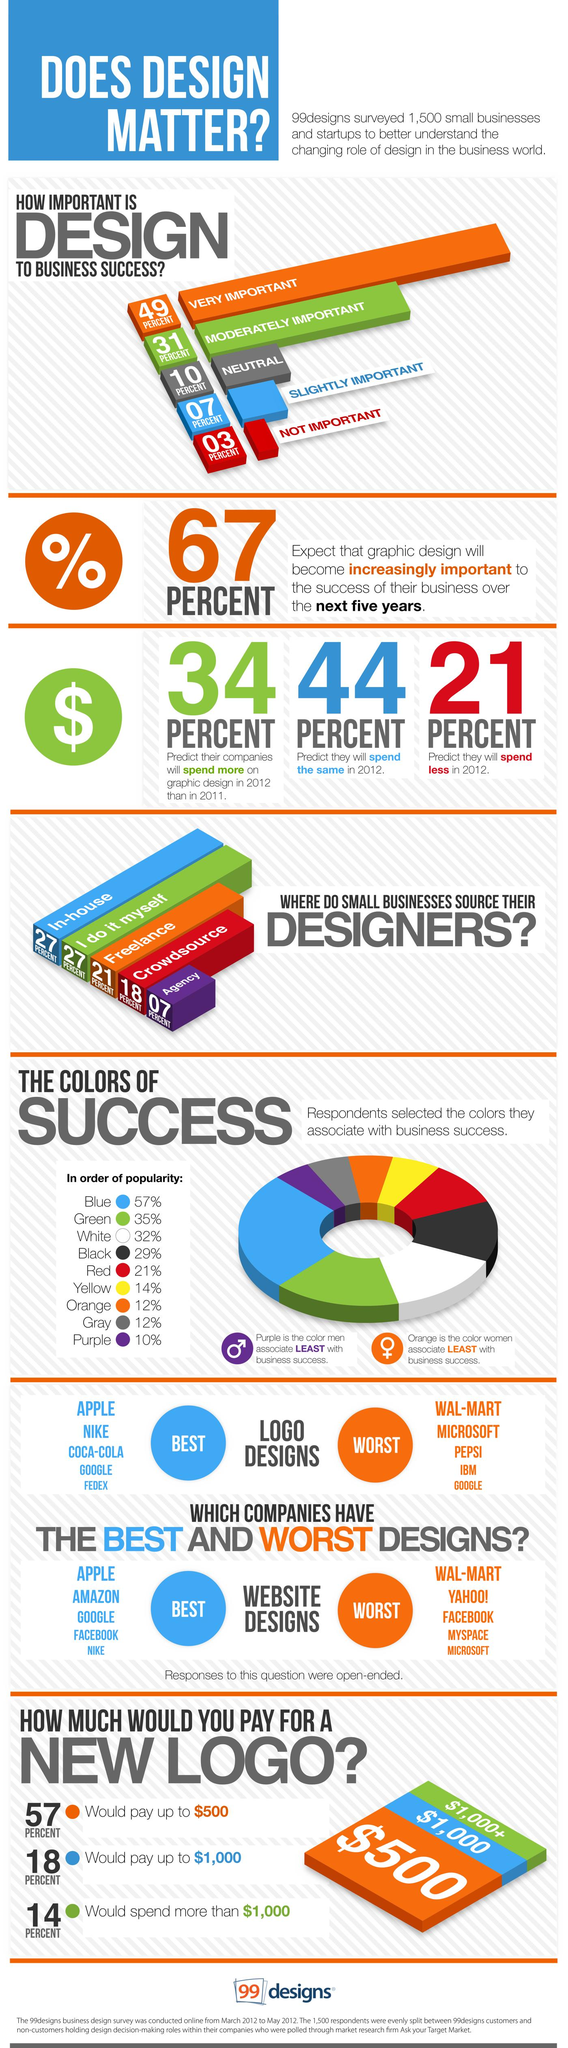List a handful of essential elements in this visual. According to the survey, 44% of respondents predict that they will spend the same in graphic design in 2012 as they did in 2011. According to the survey, 14% of respondents reported spending more than $1,000 on a new logo design. According to the survey, 21% of respondents predict that they will spend less on graphic design in 2012. According to the survey, the majority of respondents believe that design plays a very important role in business success. According to the survey, 31% of respondents believe that design is moderately important to business success. 